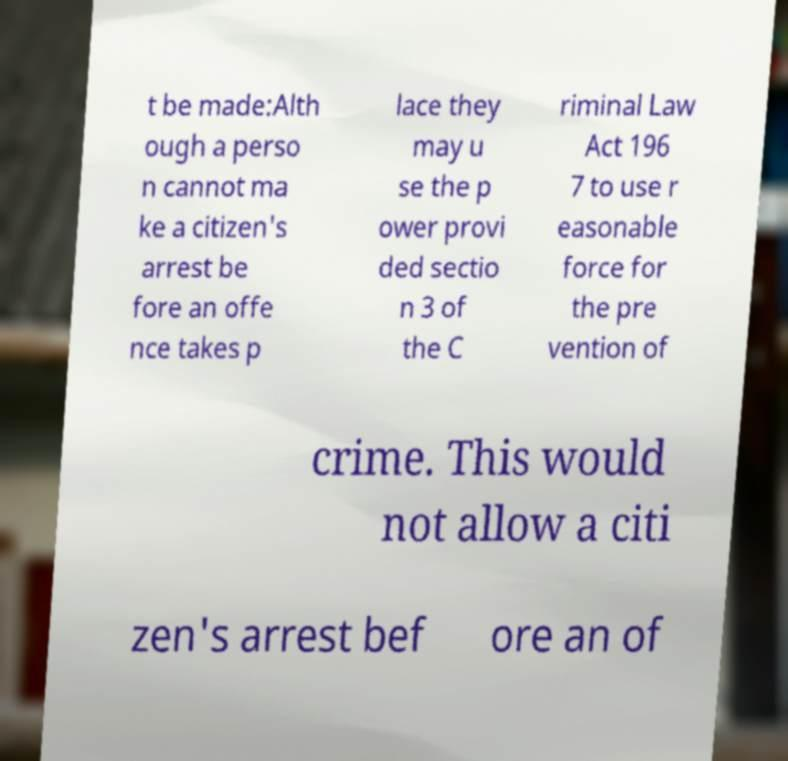Could you assist in decoding the text presented in this image and type it out clearly? t be made:Alth ough a perso n cannot ma ke a citizen's arrest be fore an offe nce takes p lace they may u se the p ower provi ded sectio n 3 of the C riminal Law Act 196 7 to use r easonable force for the pre vention of crime. This would not allow a citi zen's arrest bef ore an of 